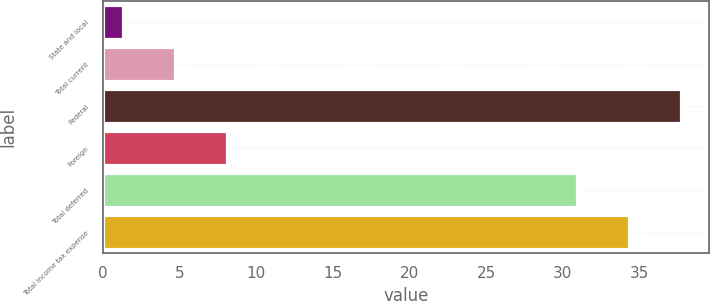Convert chart to OTSL. <chart><loc_0><loc_0><loc_500><loc_500><bar_chart><fcel>State and local<fcel>Total current<fcel>Federal<fcel>Foreign<fcel>Total deferred<fcel>Total income tax expense<nl><fcel>1.3<fcel>4.69<fcel>37.68<fcel>8.08<fcel>30.9<fcel>34.29<nl></chart> 